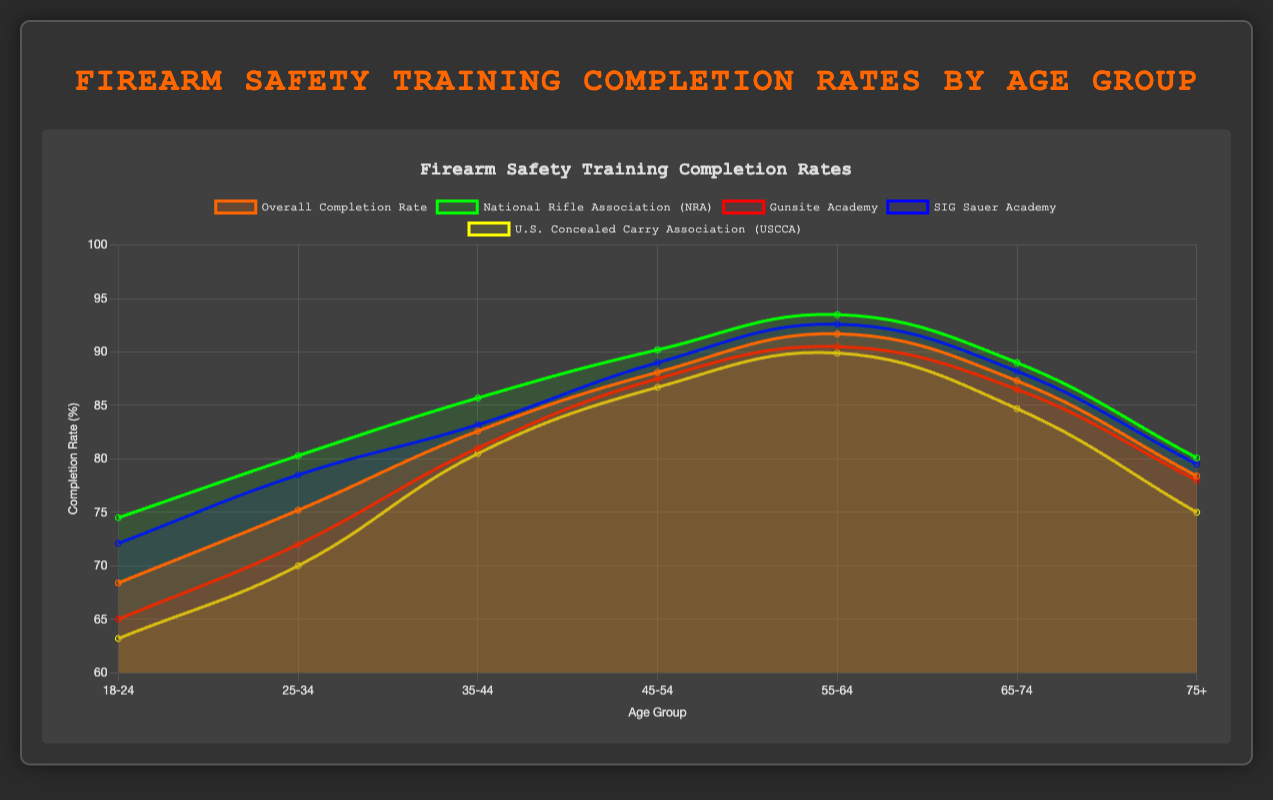Which age group has the highest overall training completion rate? The highest overall training completion rate can be found by identifying the peak value in the "Overall Completion Rate" line. This peak value is at the '55-64' age group.
Answer: 55-64 How does the training completion rate for the "National Rifle Association (NRA)" in the 18-24 age group compare to the same group’s overall rate? By looking at the "National Rifle Association (NRA)" and overall rates for the 18-24 age group in the figure, the NRA rate is higher (74.5 vs 68.4).
Answer: NRA rate is higher What is the difference in overall training completion rate between the 35-44 and 75+ age groups? The overall completion rates for the 35-44 and 75+ age groups are 82.6 and 78.4, respectively. The difference is 82.6 - 78.4.
Answer: 4.2 Which organization has the lowest training completion rate for the 25-34 age group? The data points for the 25-34 age group indicate the lowest rate among the organizations belongs to the U.S. Concealed Carry Association (USCCA) with 70.0.
Answer: U.S. Concealed Carry Association (USCCA) Visually, which organization has a line with a color that stands out for representing the "Gunsite Academy"? In the plot, the "Gunsite Academy" data line is represented by a red color.
Answer: Red What is the average training completion rate for the "SIG Sauer Academy" considering all age groups? Adding up all the percentages for "SIG Sauer Academy" across the age groups (72.1 + 78.5 + 83.2 + 89.0 + 92.6 + 88.2 + 79.5) and dividing by 7 gives the average rate. The sum is 583.1, so the average is 583.1 / 7 = 83.3.
Answer: 83.3% How much does the training completion rate for the 65-74 age group differ from the 45-54 age group for "Gunsite Academy"? Comparing the "Gunsite Academy" completion rates for 65-74 and 45-54, the rates are 86.5 and 87.5, respectively. The difference is 87.5 - 86.5.
Answer: 1 Is the training completion rate for the "U.S. Concealed Carry Association (USCCA)" higher or lower than the overall rate for the 35-44 age group? The "U.S. Concealed Carry Association (USCCA)" rate for the 35-44 age group is 80.5, which is lower than the overall rate of 82.6 for the same group.
Answer: Lower At what age group does the "National Rifle Association (NRA)" observe its peak training completion rate? The peak training completion rate for the "National Rifle Association (NRA)" is noted in the 55-64 age group, with a completion rate of 93.5.
Answer: 55-64 